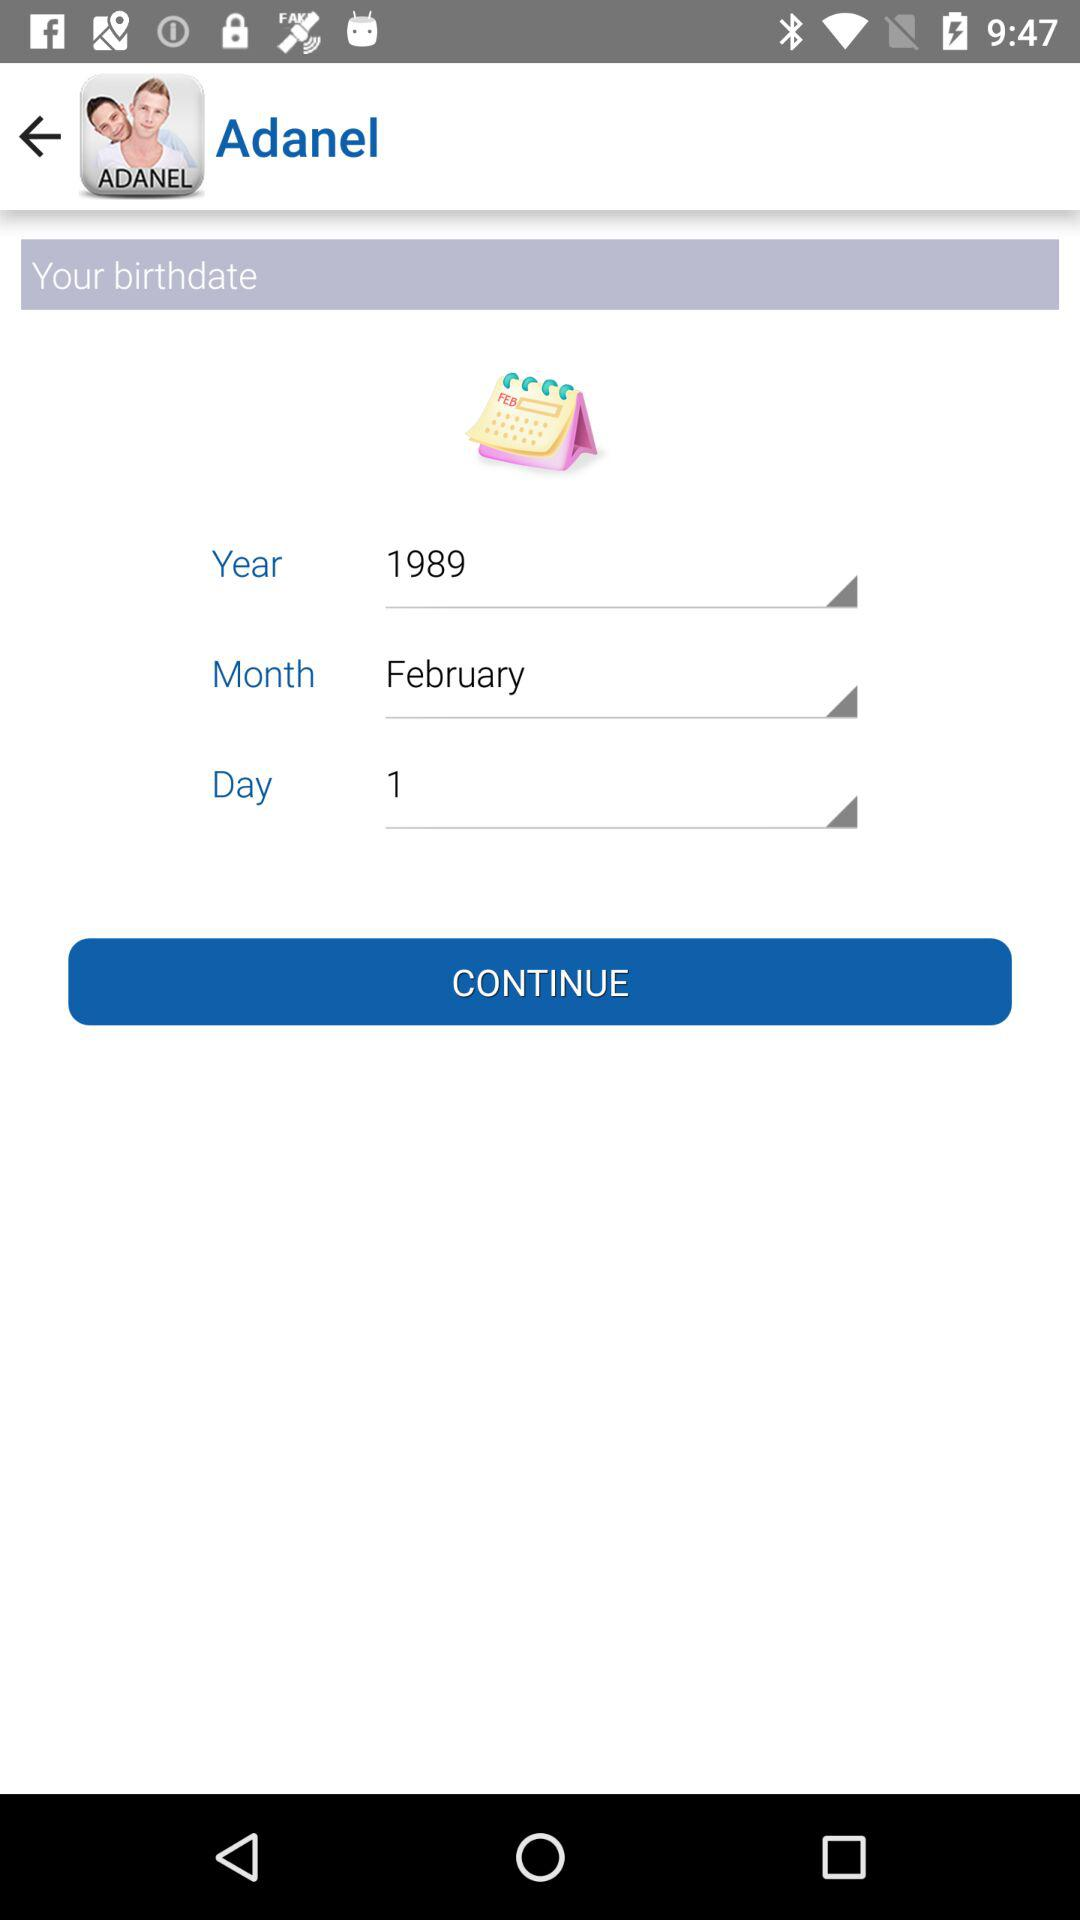What is the date of birth? The date of birth is February 1, 1989. 